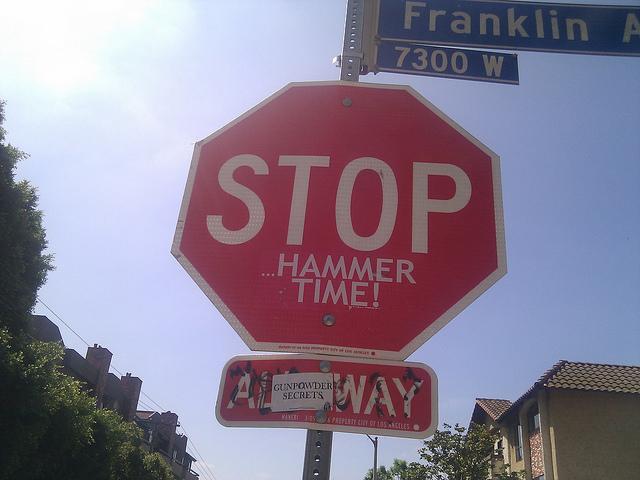What country is this?
Write a very short answer. United states. What is the English phrase on the sign?
Keep it brief. Stop hammer time. What color is the sign?
Concise answer only. Red. What time is it according to the sign?
Give a very brief answer. Hammer time. What color are the signs?
Concise answer only. Red. What number is the street?
Short answer required. 7300. 